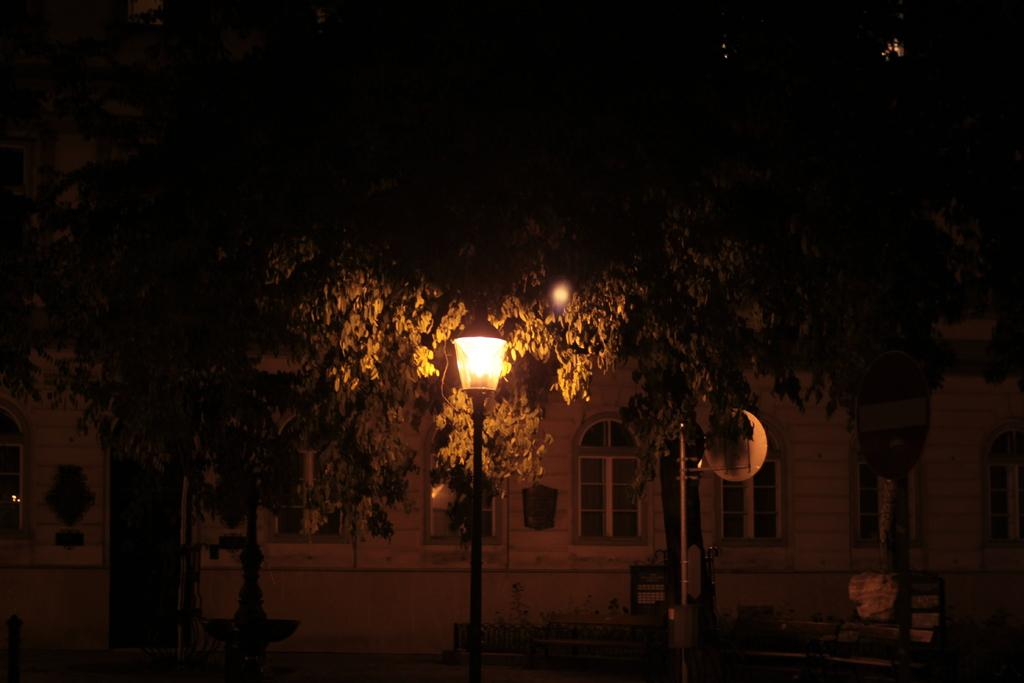Where was the picture taken? The picture was clicked outside. What can be seen in the foreground of the image? There is a lamppost, metal rods, and other items in the foreground of the image. What can be seen in the background of the image? There are green leaves and a house in the background of the image. What is the weight of the zephyr in the image? There is no zephyr present in the image, and therefore no weight can be determined. 